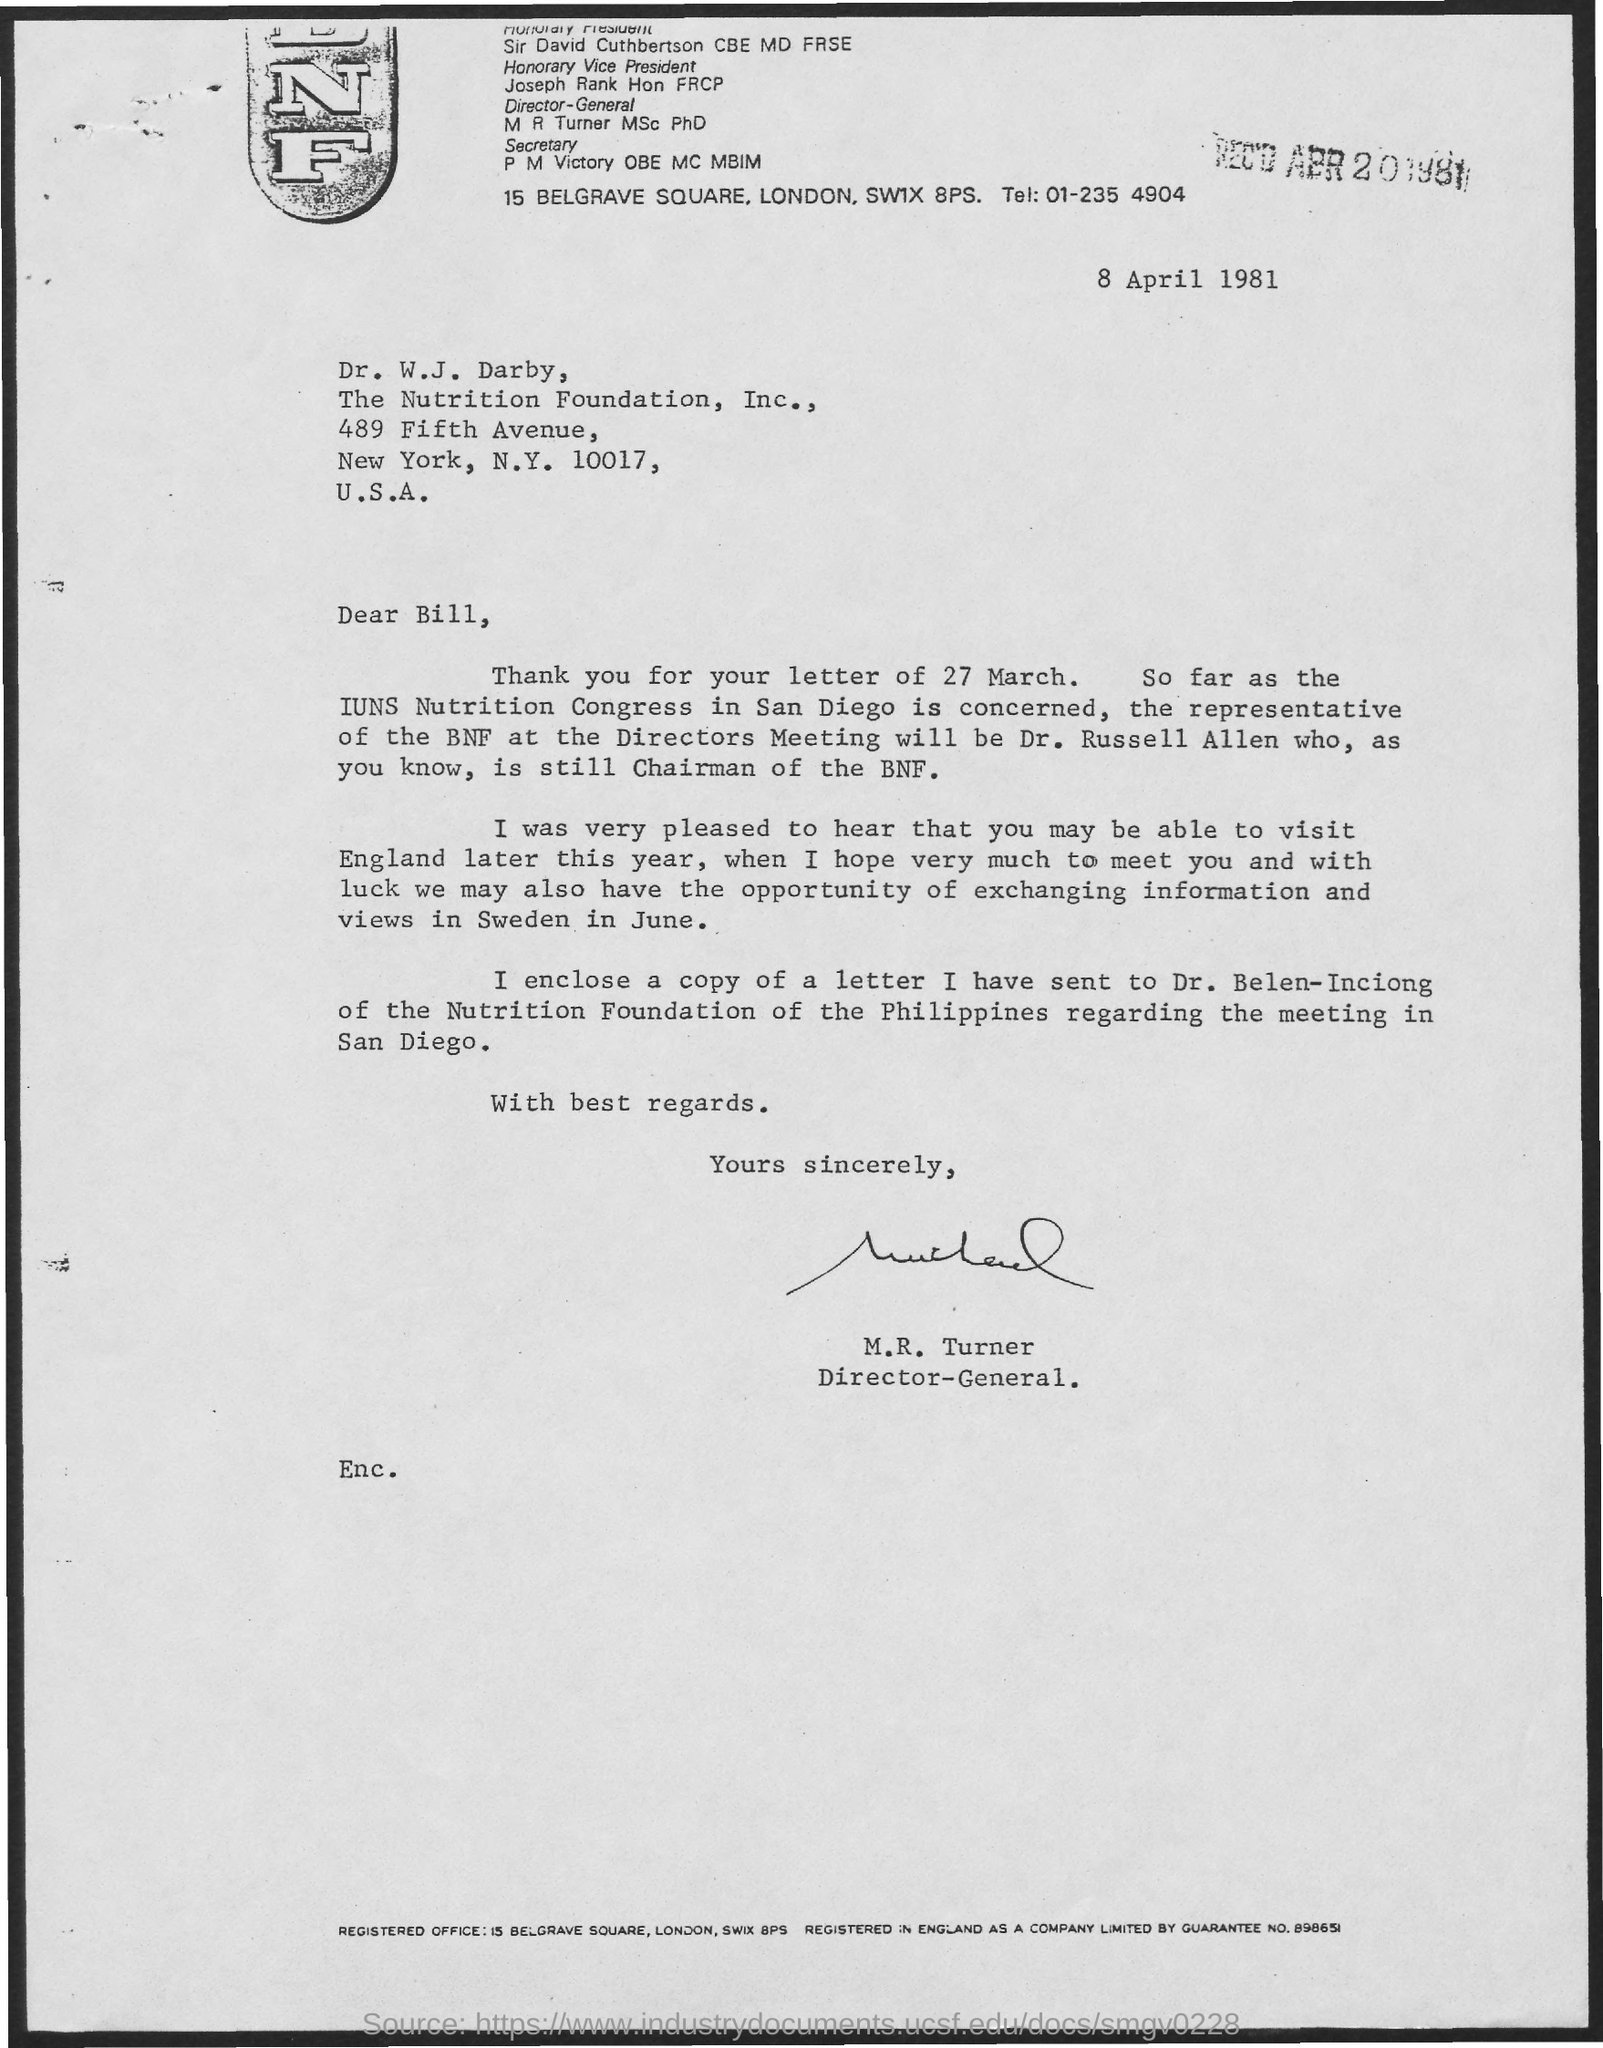Identify some key points in this picture. The letter is from M.R. Turner. The representative of the BNF at the Directors' meeting is Dr. Russell Allen. The document indicates that the date is 8 April 1981. 